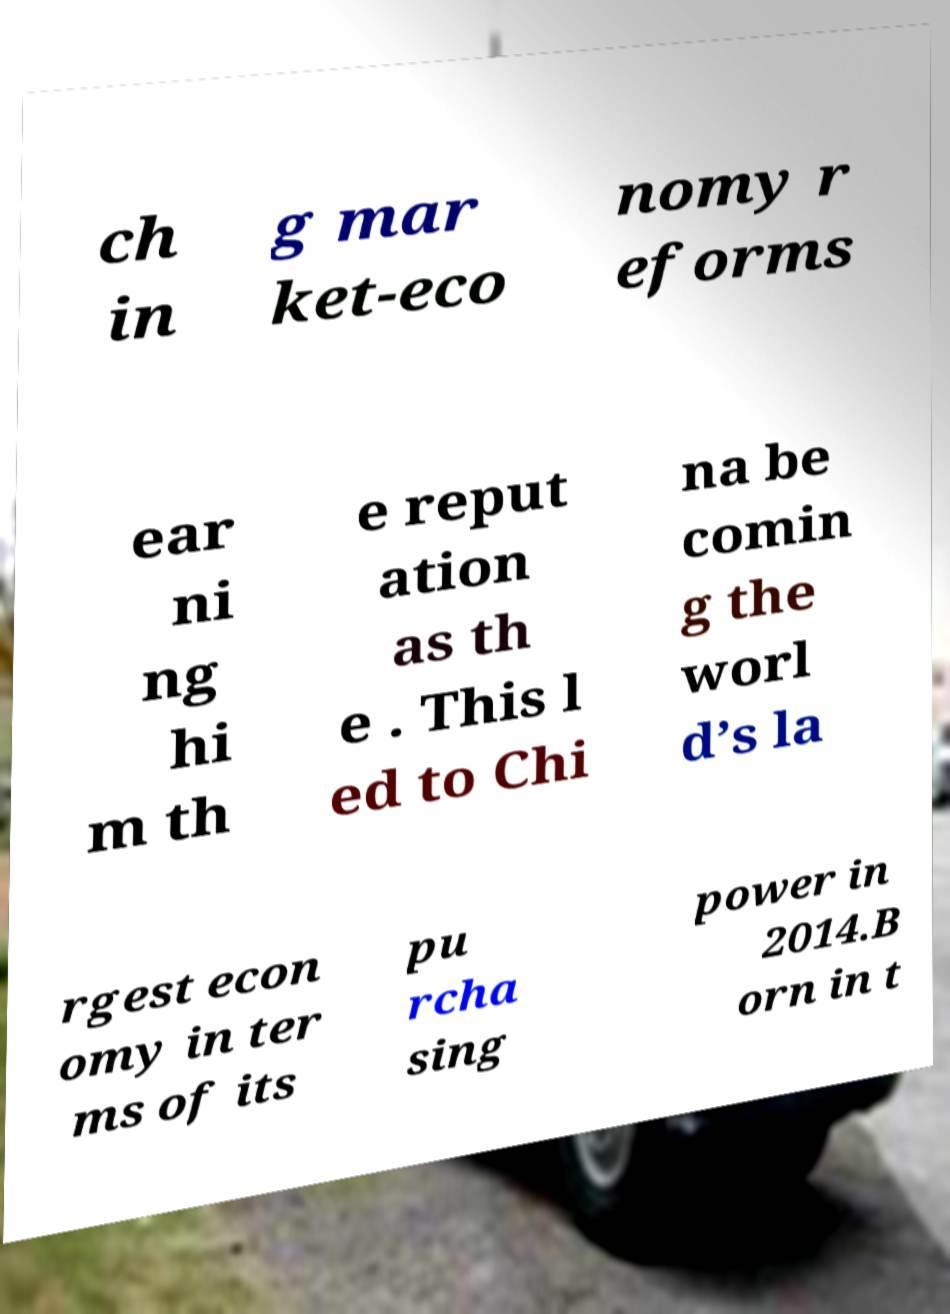For documentation purposes, I need the text within this image transcribed. Could you provide that? ch in g mar ket-eco nomy r eforms ear ni ng hi m th e reput ation as th e . This l ed to Chi na be comin g the worl d’s la rgest econ omy in ter ms of its pu rcha sing power in 2014.B orn in t 